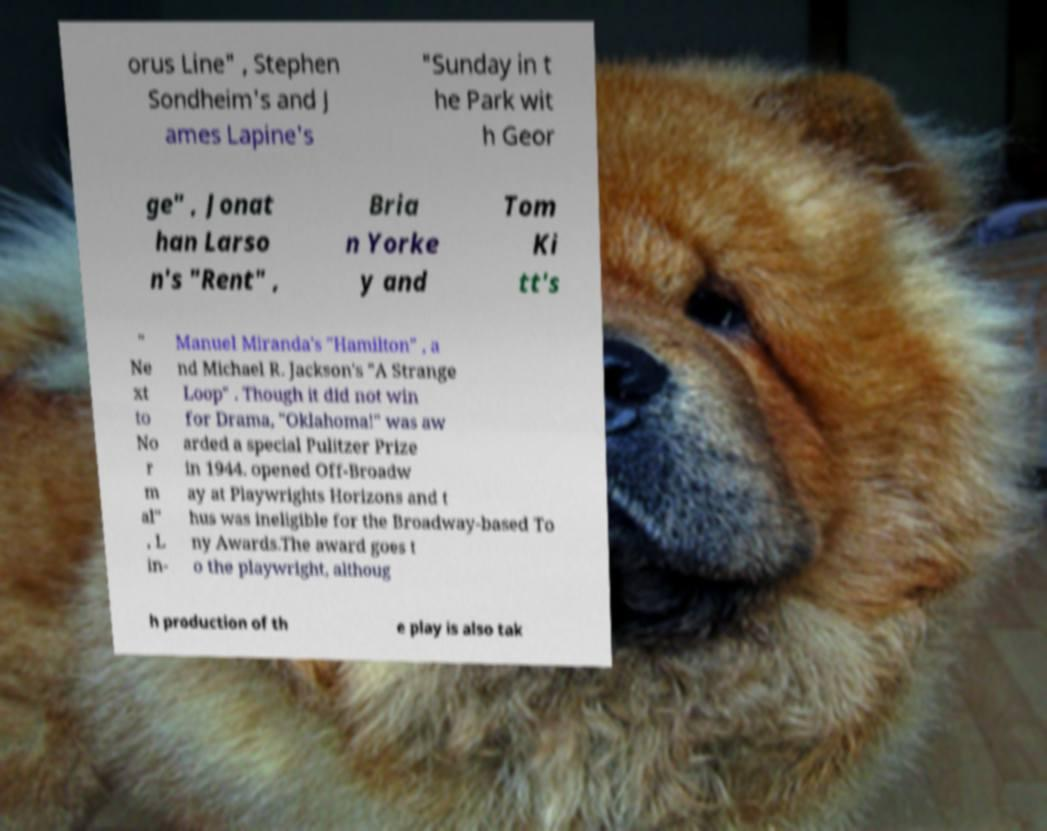What messages or text are displayed in this image? I need them in a readable, typed format. orus Line" , Stephen Sondheim's and J ames Lapine's "Sunday in t he Park wit h Geor ge" , Jonat han Larso n's "Rent" , Bria n Yorke y and Tom Ki tt's " Ne xt to No r m al" , L in- Manuel Miranda's "Hamilton" , a nd Michael R. Jackson's "A Strange Loop" . Though it did not win for Drama, "Oklahoma!" was aw arded a special Pulitzer Prize in 1944. opened Off-Broadw ay at Playwrights Horizons and t hus was ineligible for the Broadway-based To ny Awards.The award goes t o the playwright, althoug h production of th e play is also tak 